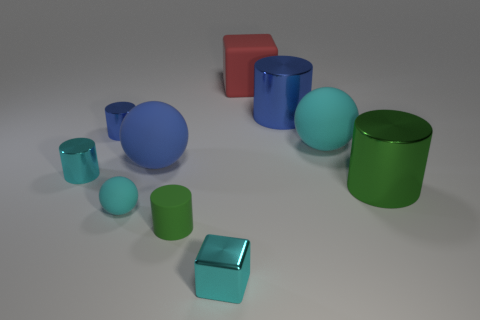The cyan object that is the same material as the small cyan cylinder is what shape?
Make the answer very short. Cube. How many brown objects are large cylinders or metallic objects?
Offer a very short reply. 0. There is a big blue metal object that is behind the tiny cyan metal object that is left of the tiny green matte thing; is there a metallic cylinder right of it?
Make the answer very short. Yes. Are there fewer rubber balls than small blue metallic cylinders?
Make the answer very short. No. There is a rubber object that is to the right of the big blue cylinder; is it the same shape as the green metallic object?
Your answer should be very brief. No. Are there any large red objects?
Provide a short and direct response. Yes. What is the color of the cube in front of the cyan ball that is on the left side of the red matte cube behind the tiny block?
Your answer should be compact. Cyan. Are there an equal number of green matte cylinders that are in front of the small cyan cube and metallic things that are left of the large cyan ball?
Your response must be concise. No. What is the shape of the blue metal object that is the same size as the blue matte ball?
Provide a short and direct response. Cylinder. Are there any other tiny matte balls of the same color as the small rubber ball?
Offer a very short reply. No. 